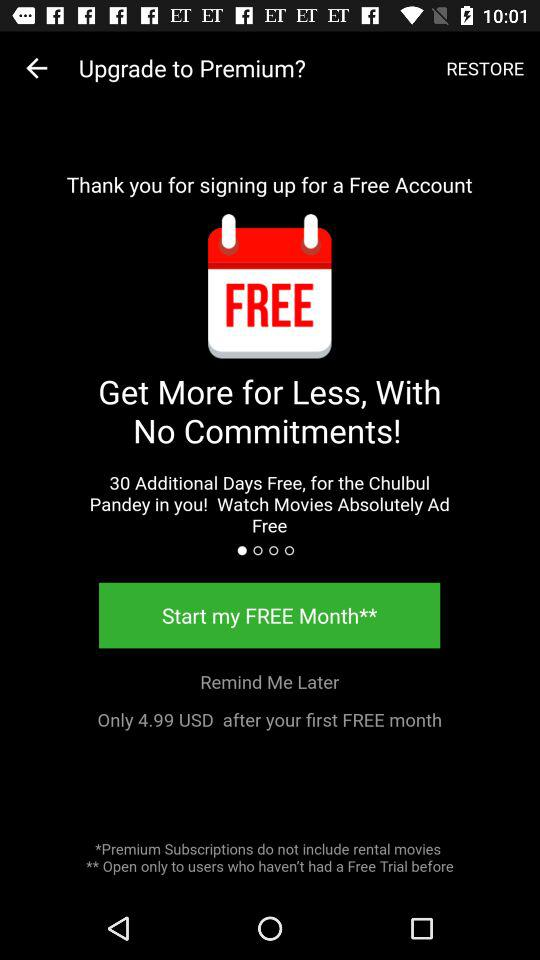How many additional days are free? There are 30 free additional days. 